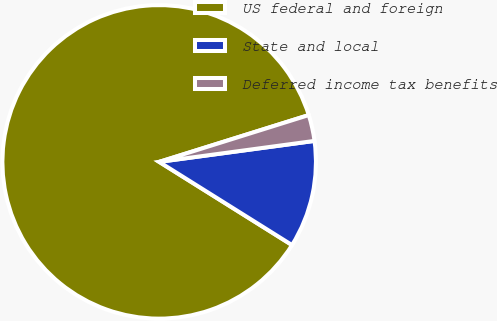<chart> <loc_0><loc_0><loc_500><loc_500><pie_chart><fcel>US federal and foreign<fcel>State and local<fcel>Deferred income tax benefits<nl><fcel>86.27%<fcel>11.04%<fcel>2.69%<nl></chart> 